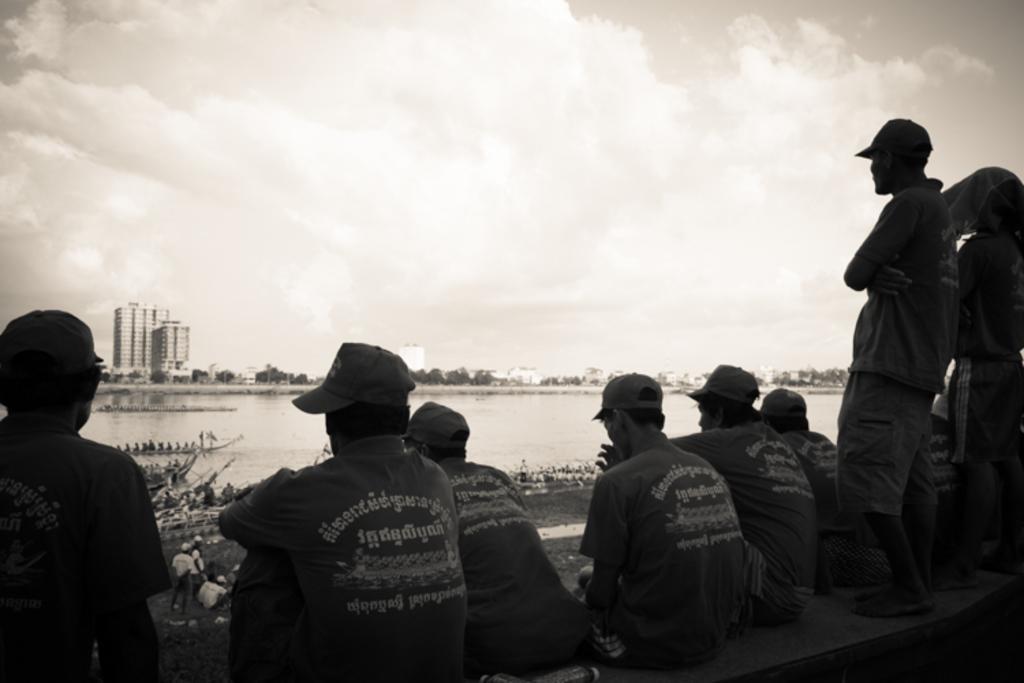How would you summarize this image in a sentence or two? In this image I can see a group of people are sitting on a fence and few are standing on grass. In the background I can see a crowd, fleets of boats in the water, trees, light poles, buildings and the sky. This image is taken may be near the lake. 